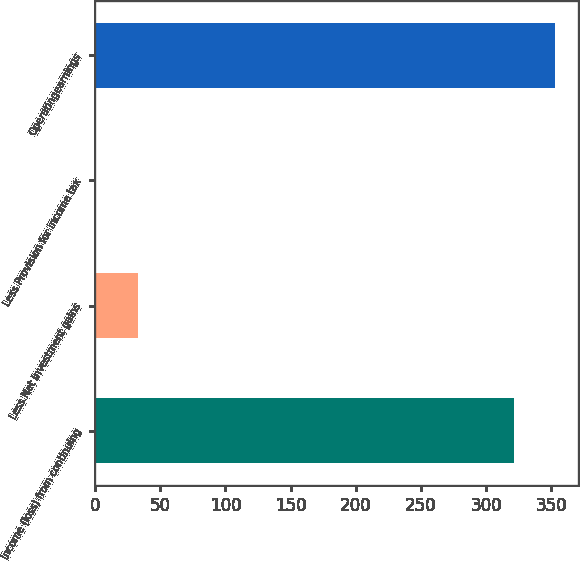<chart> <loc_0><loc_0><loc_500><loc_500><bar_chart><fcel>Income (loss) from continuing<fcel>Less Net investment gains<fcel>Less Provision for income tax<fcel>Operatingearnings<nl><fcel>321<fcel>33.1<fcel>1<fcel>353.1<nl></chart> 